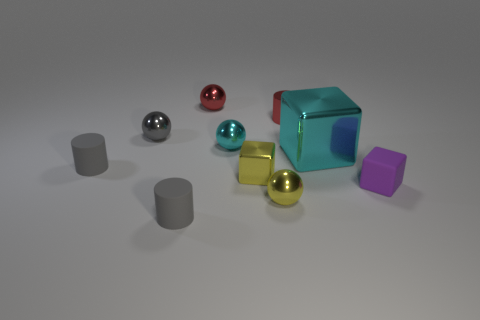Are there any patterns or textures on the objects? The objects in the image have smooth, untextured surfaces, with no visible patterns. The lights reflect off these surfaces, indicating their glossy finish. 